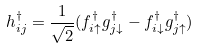Convert formula to latex. <formula><loc_0><loc_0><loc_500><loc_500>h _ { i j } ^ { \dagger } = \frac { 1 } { \sqrt { 2 } } ( f _ { i \uparrow } ^ { \dagger } g _ { j \downarrow } ^ { \dagger } - f _ { i \downarrow } ^ { \dagger } g _ { j \uparrow } ^ { \dagger } )</formula> 